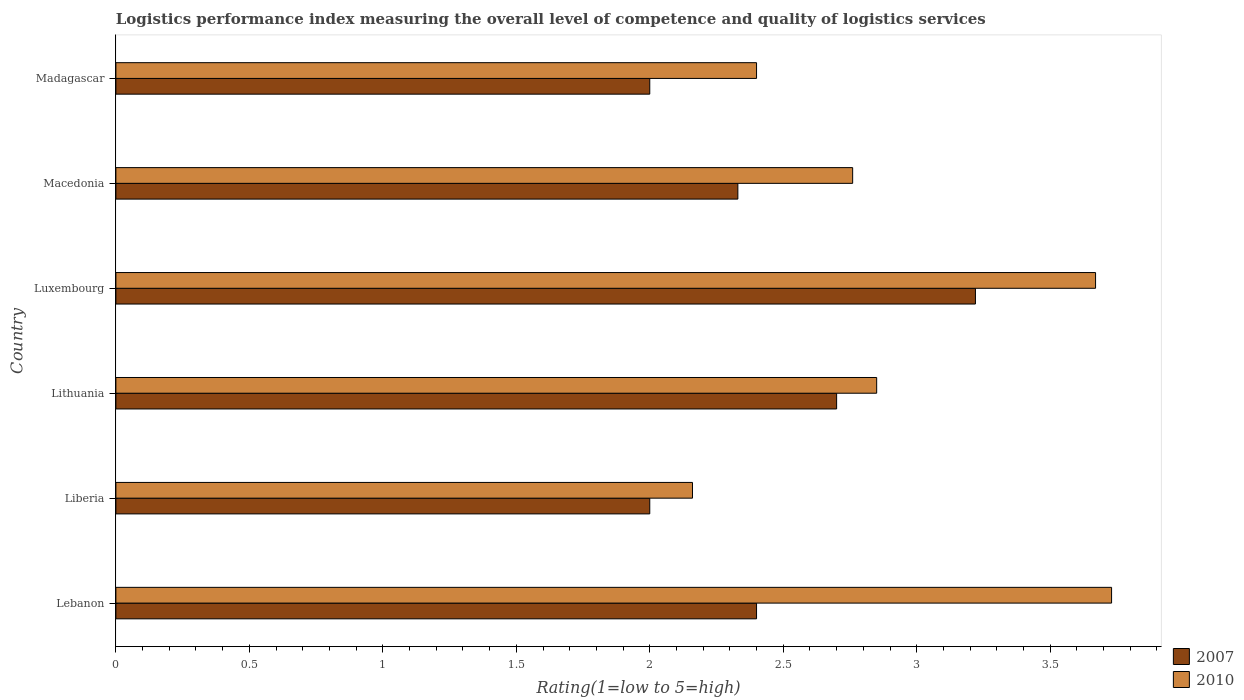How many different coloured bars are there?
Provide a short and direct response. 2. How many groups of bars are there?
Provide a short and direct response. 6. Are the number of bars per tick equal to the number of legend labels?
Give a very brief answer. Yes. How many bars are there on the 3rd tick from the top?
Give a very brief answer. 2. How many bars are there on the 2nd tick from the bottom?
Provide a succinct answer. 2. What is the label of the 5th group of bars from the top?
Your response must be concise. Liberia. In how many cases, is the number of bars for a given country not equal to the number of legend labels?
Offer a terse response. 0. What is the Logistic performance index in 2010 in Liberia?
Offer a very short reply. 2.16. Across all countries, what is the maximum Logistic performance index in 2007?
Provide a short and direct response. 3.22. Across all countries, what is the minimum Logistic performance index in 2010?
Make the answer very short. 2.16. In which country was the Logistic performance index in 2007 maximum?
Give a very brief answer. Luxembourg. In which country was the Logistic performance index in 2010 minimum?
Ensure brevity in your answer.  Liberia. What is the total Logistic performance index in 2007 in the graph?
Offer a very short reply. 14.65. What is the difference between the Logistic performance index in 2007 in Lithuania and that in Madagascar?
Provide a short and direct response. 0.7. What is the difference between the Logistic performance index in 2010 in Macedonia and the Logistic performance index in 2007 in Lithuania?
Your answer should be very brief. 0.06. What is the average Logistic performance index in 2010 per country?
Provide a succinct answer. 2.93. What is the difference between the Logistic performance index in 2007 and Logistic performance index in 2010 in Lithuania?
Make the answer very short. -0.15. What is the ratio of the Logistic performance index in 2010 in Lithuania to that in Madagascar?
Your answer should be very brief. 1.19. What is the difference between the highest and the second highest Logistic performance index in 2010?
Your answer should be compact. 0.06. What is the difference between the highest and the lowest Logistic performance index in 2007?
Offer a very short reply. 1.22. In how many countries, is the Logistic performance index in 2010 greater than the average Logistic performance index in 2010 taken over all countries?
Your answer should be very brief. 2. What does the 1st bar from the top in Lithuania represents?
Offer a very short reply. 2010. What does the 2nd bar from the bottom in Lebanon represents?
Make the answer very short. 2010. Does the graph contain any zero values?
Your answer should be very brief. No. Where does the legend appear in the graph?
Ensure brevity in your answer.  Bottom right. How many legend labels are there?
Your answer should be very brief. 2. What is the title of the graph?
Make the answer very short. Logistics performance index measuring the overall level of competence and quality of logistics services. What is the label or title of the X-axis?
Offer a very short reply. Rating(1=low to 5=high). What is the Rating(1=low to 5=high) in 2007 in Lebanon?
Make the answer very short. 2.4. What is the Rating(1=low to 5=high) of 2010 in Lebanon?
Make the answer very short. 3.73. What is the Rating(1=low to 5=high) in 2010 in Liberia?
Ensure brevity in your answer.  2.16. What is the Rating(1=low to 5=high) in 2010 in Lithuania?
Offer a very short reply. 2.85. What is the Rating(1=low to 5=high) in 2007 in Luxembourg?
Your answer should be compact. 3.22. What is the Rating(1=low to 5=high) of 2010 in Luxembourg?
Ensure brevity in your answer.  3.67. What is the Rating(1=low to 5=high) of 2007 in Macedonia?
Keep it short and to the point. 2.33. What is the Rating(1=low to 5=high) of 2010 in Macedonia?
Ensure brevity in your answer.  2.76. What is the Rating(1=low to 5=high) of 2010 in Madagascar?
Offer a terse response. 2.4. Across all countries, what is the maximum Rating(1=low to 5=high) of 2007?
Provide a succinct answer. 3.22. Across all countries, what is the maximum Rating(1=low to 5=high) of 2010?
Your response must be concise. 3.73. Across all countries, what is the minimum Rating(1=low to 5=high) in 2007?
Your answer should be compact. 2. Across all countries, what is the minimum Rating(1=low to 5=high) in 2010?
Your answer should be very brief. 2.16. What is the total Rating(1=low to 5=high) in 2007 in the graph?
Provide a short and direct response. 14.65. What is the total Rating(1=low to 5=high) in 2010 in the graph?
Your answer should be very brief. 17.57. What is the difference between the Rating(1=low to 5=high) of 2010 in Lebanon and that in Liberia?
Provide a short and direct response. 1.57. What is the difference between the Rating(1=low to 5=high) in 2010 in Lebanon and that in Lithuania?
Keep it short and to the point. 0.88. What is the difference between the Rating(1=low to 5=high) of 2007 in Lebanon and that in Luxembourg?
Your answer should be compact. -0.82. What is the difference between the Rating(1=low to 5=high) of 2007 in Lebanon and that in Macedonia?
Ensure brevity in your answer.  0.07. What is the difference between the Rating(1=low to 5=high) in 2007 in Lebanon and that in Madagascar?
Ensure brevity in your answer.  0.4. What is the difference between the Rating(1=low to 5=high) in 2010 in Lebanon and that in Madagascar?
Your response must be concise. 1.33. What is the difference between the Rating(1=low to 5=high) of 2007 in Liberia and that in Lithuania?
Keep it short and to the point. -0.7. What is the difference between the Rating(1=low to 5=high) of 2010 in Liberia and that in Lithuania?
Your answer should be compact. -0.69. What is the difference between the Rating(1=low to 5=high) in 2007 in Liberia and that in Luxembourg?
Offer a very short reply. -1.22. What is the difference between the Rating(1=low to 5=high) of 2010 in Liberia and that in Luxembourg?
Make the answer very short. -1.51. What is the difference between the Rating(1=low to 5=high) in 2007 in Liberia and that in Macedonia?
Your answer should be compact. -0.33. What is the difference between the Rating(1=low to 5=high) in 2010 in Liberia and that in Macedonia?
Offer a terse response. -0.6. What is the difference between the Rating(1=low to 5=high) of 2007 in Liberia and that in Madagascar?
Provide a short and direct response. 0. What is the difference between the Rating(1=low to 5=high) of 2010 in Liberia and that in Madagascar?
Your answer should be very brief. -0.24. What is the difference between the Rating(1=low to 5=high) of 2007 in Lithuania and that in Luxembourg?
Make the answer very short. -0.52. What is the difference between the Rating(1=low to 5=high) in 2010 in Lithuania and that in Luxembourg?
Your response must be concise. -0.82. What is the difference between the Rating(1=low to 5=high) of 2007 in Lithuania and that in Macedonia?
Your answer should be very brief. 0.37. What is the difference between the Rating(1=low to 5=high) of 2010 in Lithuania and that in Macedonia?
Offer a very short reply. 0.09. What is the difference between the Rating(1=low to 5=high) in 2007 in Lithuania and that in Madagascar?
Make the answer very short. 0.7. What is the difference between the Rating(1=low to 5=high) of 2010 in Lithuania and that in Madagascar?
Give a very brief answer. 0.45. What is the difference between the Rating(1=low to 5=high) in 2007 in Luxembourg and that in Macedonia?
Your answer should be very brief. 0.89. What is the difference between the Rating(1=low to 5=high) of 2010 in Luxembourg and that in Macedonia?
Provide a short and direct response. 0.91. What is the difference between the Rating(1=low to 5=high) in 2007 in Luxembourg and that in Madagascar?
Provide a short and direct response. 1.22. What is the difference between the Rating(1=low to 5=high) of 2010 in Luxembourg and that in Madagascar?
Offer a very short reply. 1.27. What is the difference between the Rating(1=low to 5=high) in 2007 in Macedonia and that in Madagascar?
Ensure brevity in your answer.  0.33. What is the difference between the Rating(1=low to 5=high) in 2010 in Macedonia and that in Madagascar?
Make the answer very short. 0.36. What is the difference between the Rating(1=low to 5=high) in 2007 in Lebanon and the Rating(1=low to 5=high) in 2010 in Liberia?
Ensure brevity in your answer.  0.24. What is the difference between the Rating(1=low to 5=high) in 2007 in Lebanon and the Rating(1=low to 5=high) in 2010 in Lithuania?
Offer a very short reply. -0.45. What is the difference between the Rating(1=low to 5=high) in 2007 in Lebanon and the Rating(1=low to 5=high) in 2010 in Luxembourg?
Ensure brevity in your answer.  -1.27. What is the difference between the Rating(1=low to 5=high) in 2007 in Lebanon and the Rating(1=low to 5=high) in 2010 in Macedonia?
Provide a succinct answer. -0.36. What is the difference between the Rating(1=low to 5=high) in 2007 in Liberia and the Rating(1=low to 5=high) in 2010 in Lithuania?
Provide a succinct answer. -0.85. What is the difference between the Rating(1=low to 5=high) of 2007 in Liberia and the Rating(1=low to 5=high) of 2010 in Luxembourg?
Your answer should be very brief. -1.67. What is the difference between the Rating(1=low to 5=high) of 2007 in Liberia and the Rating(1=low to 5=high) of 2010 in Macedonia?
Provide a succinct answer. -0.76. What is the difference between the Rating(1=low to 5=high) of 2007 in Liberia and the Rating(1=low to 5=high) of 2010 in Madagascar?
Make the answer very short. -0.4. What is the difference between the Rating(1=low to 5=high) in 2007 in Lithuania and the Rating(1=low to 5=high) in 2010 in Luxembourg?
Make the answer very short. -0.97. What is the difference between the Rating(1=low to 5=high) of 2007 in Lithuania and the Rating(1=low to 5=high) of 2010 in Macedonia?
Offer a terse response. -0.06. What is the difference between the Rating(1=low to 5=high) of 2007 in Luxembourg and the Rating(1=low to 5=high) of 2010 in Macedonia?
Offer a very short reply. 0.46. What is the difference between the Rating(1=low to 5=high) in 2007 in Luxembourg and the Rating(1=low to 5=high) in 2010 in Madagascar?
Provide a short and direct response. 0.82. What is the difference between the Rating(1=low to 5=high) of 2007 in Macedonia and the Rating(1=low to 5=high) of 2010 in Madagascar?
Provide a succinct answer. -0.07. What is the average Rating(1=low to 5=high) of 2007 per country?
Give a very brief answer. 2.44. What is the average Rating(1=low to 5=high) of 2010 per country?
Provide a succinct answer. 2.93. What is the difference between the Rating(1=low to 5=high) in 2007 and Rating(1=low to 5=high) in 2010 in Lebanon?
Ensure brevity in your answer.  -1.33. What is the difference between the Rating(1=low to 5=high) of 2007 and Rating(1=low to 5=high) of 2010 in Liberia?
Offer a very short reply. -0.16. What is the difference between the Rating(1=low to 5=high) in 2007 and Rating(1=low to 5=high) in 2010 in Lithuania?
Your answer should be very brief. -0.15. What is the difference between the Rating(1=low to 5=high) in 2007 and Rating(1=low to 5=high) in 2010 in Luxembourg?
Your answer should be compact. -0.45. What is the difference between the Rating(1=low to 5=high) in 2007 and Rating(1=low to 5=high) in 2010 in Macedonia?
Your answer should be very brief. -0.43. What is the difference between the Rating(1=low to 5=high) in 2007 and Rating(1=low to 5=high) in 2010 in Madagascar?
Offer a very short reply. -0.4. What is the ratio of the Rating(1=low to 5=high) of 2007 in Lebanon to that in Liberia?
Give a very brief answer. 1.2. What is the ratio of the Rating(1=low to 5=high) in 2010 in Lebanon to that in Liberia?
Make the answer very short. 1.73. What is the ratio of the Rating(1=low to 5=high) of 2007 in Lebanon to that in Lithuania?
Make the answer very short. 0.89. What is the ratio of the Rating(1=low to 5=high) of 2010 in Lebanon to that in Lithuania?
Keep it short and to the point. 1.31. What is the ratio of the Rating(1=low to 5=high) in 2007 in Lebanon to that in Luxembourg?
Offer a terse response. 0.75. What is the ratio of the Rating(1=low to 5=high) of 2010 in Lebanon to that in Luxembourg?
Your answer should be very brief. 1.02. What is the ratio of the Rating(1=low to 5=high) in 2010 in Lebanon to that in Macedonia?
Give a very brief answer. 1.35. What is the ratio of the Rating(1=low to 5=high) of 2010 in Lebanon to that in Madagascar?
Provide a short and direct response. 1.55. What is the ratio of the Rating(1=low to 5=high) in 2007 in Liberia to that in Lithuania?
Offer a very short reply. 0.74. What is the ratio of the Rating(1=low to 5=high) of 2010 in Liberia to that in Lithuania?
Ensure brevity in your answer.  0.76. What is the ratio of the Rating(1=low to 5=high) of 2007 in Liberia to that in Luxembourg?
Keep it short and to the point. 0.62. What is the ratio of the Rating(1=low to 5=high) of 2010 in Liberia to that in Luxembourg?
Your response must be concise. 0.59. What is the ratio of the Rating(1=low to 5=high) of 2007 in Liberia to that in Macedonia?
Provide a succinct answer. 0.86. What is the ratio of the Rating(1=low to 5=high) in 2010 in Liberia to that in Macedonia?
Provide a succinct answer. 0.78. What is the ratio of the Rating(1=low to 5=high) in 2007 in Lithuania to that in Luxembourg?
Your response must be concise. 0.84. What is the ratio of the Rating(1=low to 5=high) of 2010 in Lithuania to that in Luxembourg?
Ensure brevity in your answer.  0.78. What is the ratio of the Rating(1=low to 5=high) of 2007 in Lithuania to that in Macedonia?
Offer a very short reply. 1.16. What is the ratio of the Rating(1=low to 5=high) in 2010 in Lithuania to that in Macedonia?
Provide a succinct answer. 1.03. What is the ratio of the Rating(1=low to 5=high) in 2007 in Lithuania to that in Madagascar?
Provide a succinct answer. 1.35. What is the ratio of the Rating(1=low to 5=high) in 2010 in Lithuania to that in Madagascar?
Your response must be concise. 1.19. What is the ratio of the Rating(1=low to 5=high) in 2007 in Luxembourg to that in Macedonia?
Make the answer very short. 1.38. What is the ratio of the Rating(1=low to 5=high) of 2010 in Luxembourg to that in Macedonia?
Give a very brief answer. 1.33. What is the ratio of the Rating(1=low to 5=high) in 2007 in Luxembourg to that in Madagascar?
Provide a succinct answer. 1.61. What is the ratio of the Rating(1=low to 5=high) of 2010 in Luxembourg to that in Madagascar?
Give a very brief answer. 1.53. What is the ratio of the Rating(1=low to 5=high) in 2007 in Macedonia to that in Madagascar?
Your response must be concise. 1.17. What is the ratio of the Rating(1=low to 5=high) in 2010 in Macedonia to that in Madagascar?
Give a very brief answer. 1.15. What is the difference between the highest and the second highest Rating(1=low to 5=high) of 2007?
Ensure brevity in your answer.  0.52. What is the difference between the highest and the lowest Rating(1=low to 5=high) of 2007?
Your answer should be very brief. 1.22. What is the difference between the highest and the lowest Rating(1=low to 5=high) of 2010?
Offer a very short reply. 1.57. 